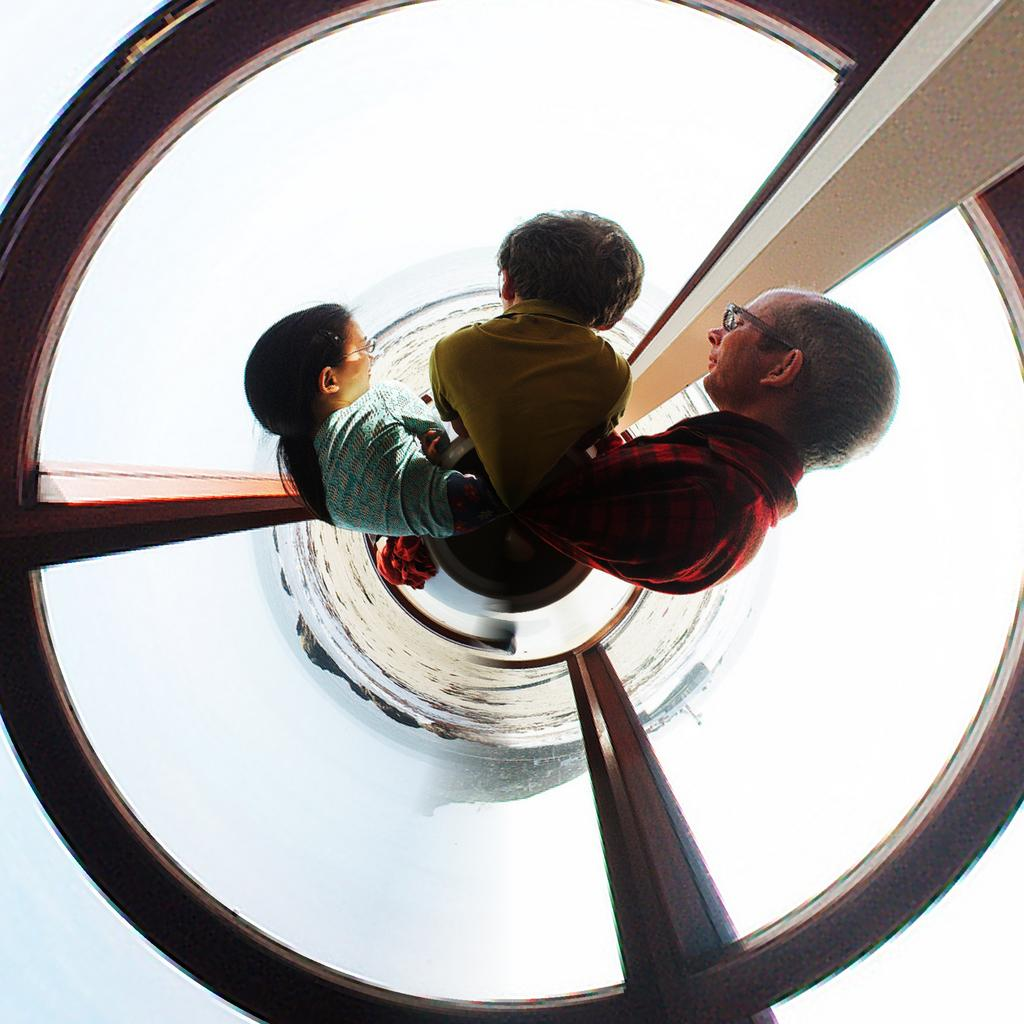From what angle was the image taken? The image is taken from a top angle. How many people are in the image? There are three people in the image. Where are the people located in the image? The people are standing in a cylindrical glass structure. What can be seen inside the structure with the people? There are wooden poles in the structure. How much profit did the people make while standing in the structure? There is no information about profit in the image, as it only shows people standing in a cylindrical glass structure with wooden poles. 